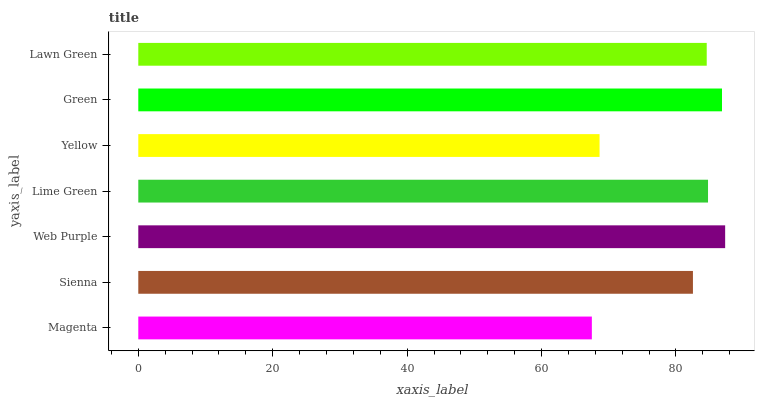Is Magenta the minimum?
Answer yes or no. Yes. Is Web Purple the maximum?
Answer yes or no. Yes. Is Sienna the minimum?
Answer yes or no. No. Is Sienna the maximum?
Answer yes or no. No. Is Sienna greater than Magenta?
Answer yes or no. Yes. Is Magenta less than Sienna?
Answer yes or no. Yes. Is Magenta greater than Sienna?
Answer yes or no. No. Is Sienna less than Magenta?
Answer yes or no. No. Is Lawn Green the high median?
Answer yes or no. Yes. Is Lawn Green the low median?
Answer yes or no. Yes. Is Lime Green the high median?
Answer yes or no. No. Is Yellow the low median?
Answer yes or no. No. 